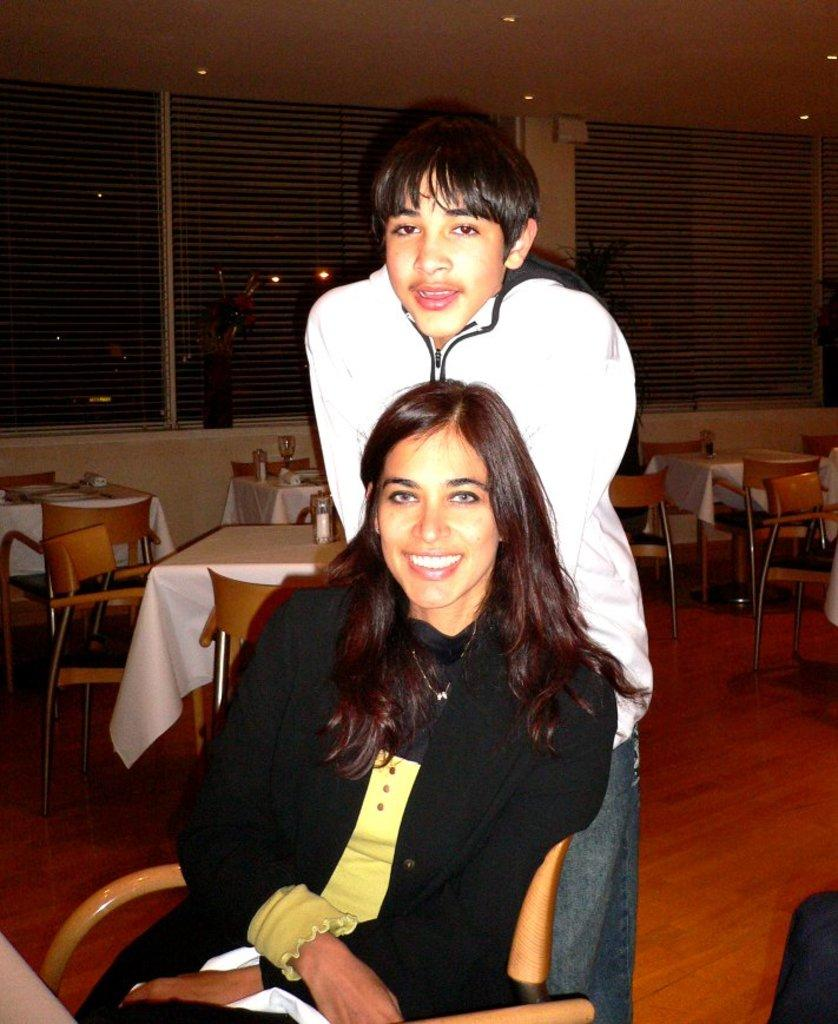What type of openings can be seen in the image? There are windows in the image. What type of furniture is present in the image? There are chairs and tables in the image. How many people are visible in the image? There are two people in the image. What type of government is depicted in the image? There is no depiction of a government in the image; it features windows, chairs, tables, and two people. What arithmetic problem can be solved using the number of chairs in the image? There is no arithmetic problem related to the number of chairs in the image; it simply shows the presence of chairs. 